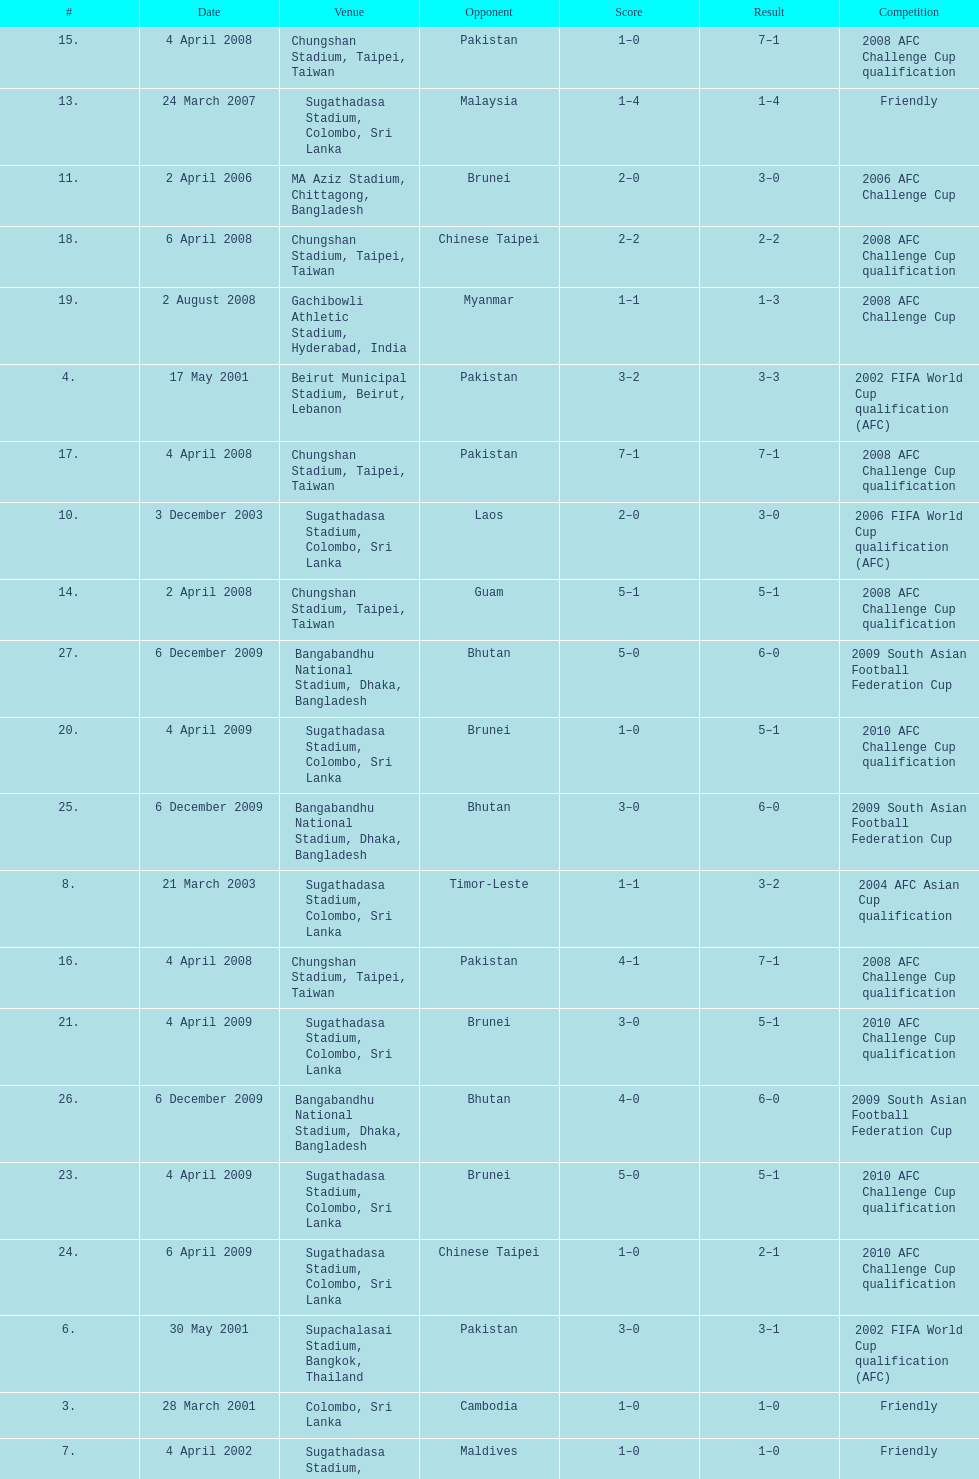Were more competitions played in april or december? April. 